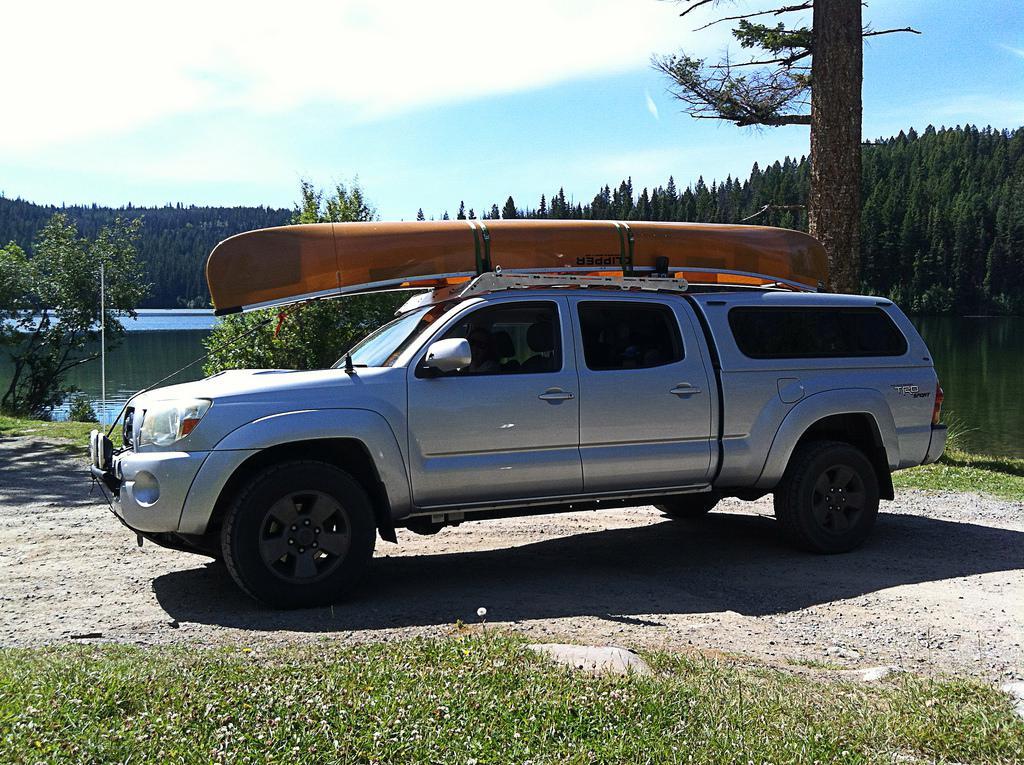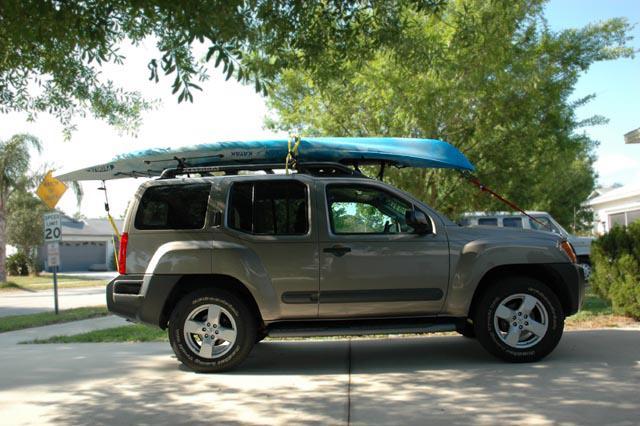The first image is the image on the left, the second image is the image on the right. Considering the images on both sides, is "A dark green canoe is on top of an open-bed pickup truck." valid? Answer yes or no. No. 